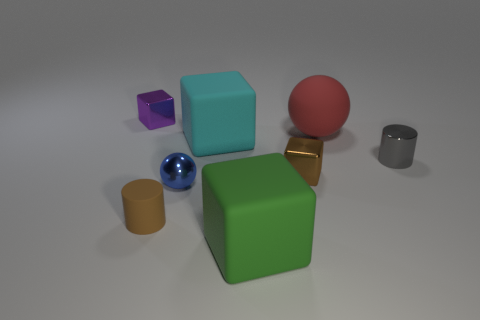Subtract 1 blocks. How many blocks are left? 3 Add 1 cyan shiny things. How many objects exist? 9 Subtract all balls. How many objects are left? 6 Add 7 small blue matte objects. How many small blue matte objects exist? 7 Subtract 0 purple balls. How many objects are left? 8 Subtract all small blue balls. Subtract all brown objects. How many objects are left? 5 Add 4 cyan objects. How many cyan objects are left? 5 